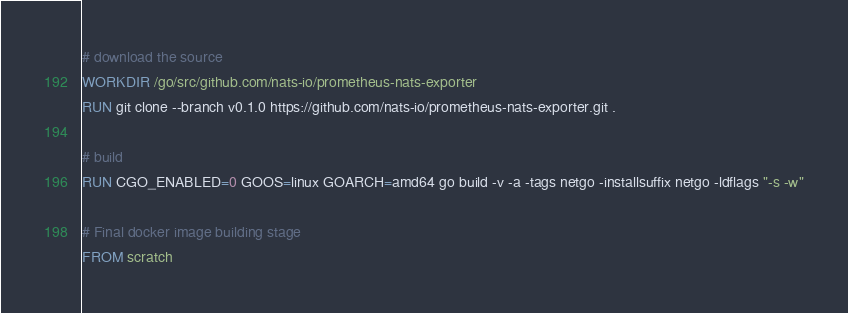Convert code to text. <code><loc_0><loc_0><loc_500><loc_500><_Dockerfile_>
# download the source
WORKDIR /go/src/github.com/nats-io/prometheus-nats-exporter
RUN git clone --branch v0.1.0 https://github.com/nats-io/prometheus-nats-exporter.git .

# build
RUN CGO_ENABLED=0 GOOS=linux GOARCH=amd64 go build -v -a -tags netgo -installsuffix netgo -ldflags "-s -w"

# Final docker image building stage
FROM scratch</code> 